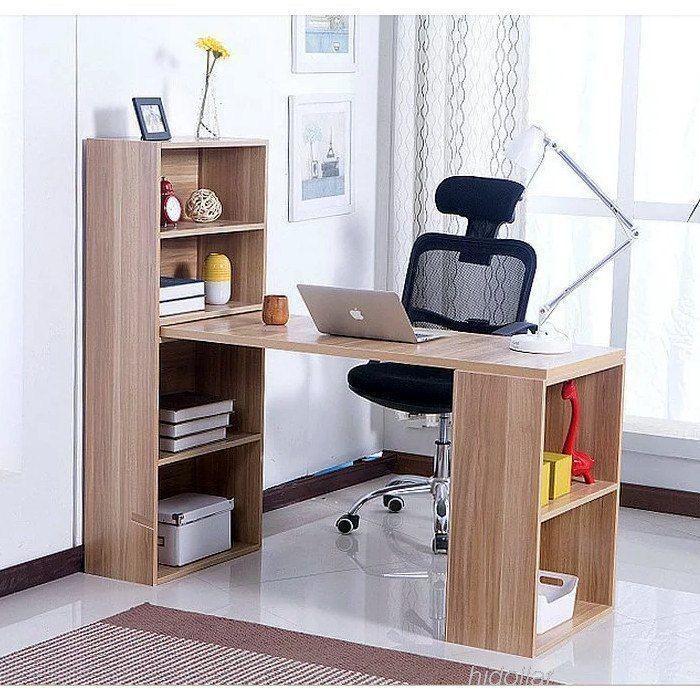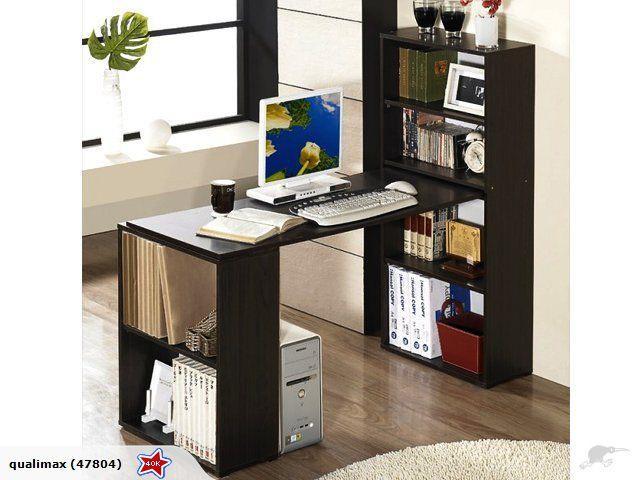The first image is the image on the left, the second image is the image on the right. For the images displayed, is the sentence "There is a chair on wheels next to a desk." factually correct? Answer yes or no. Yes. The first image is the image on the left, the second image is the image on the right. For the images displayed, is the sentence "There is a chair pulled up to at least one of the desks." factually correct? Answer yes or no. Yes. 